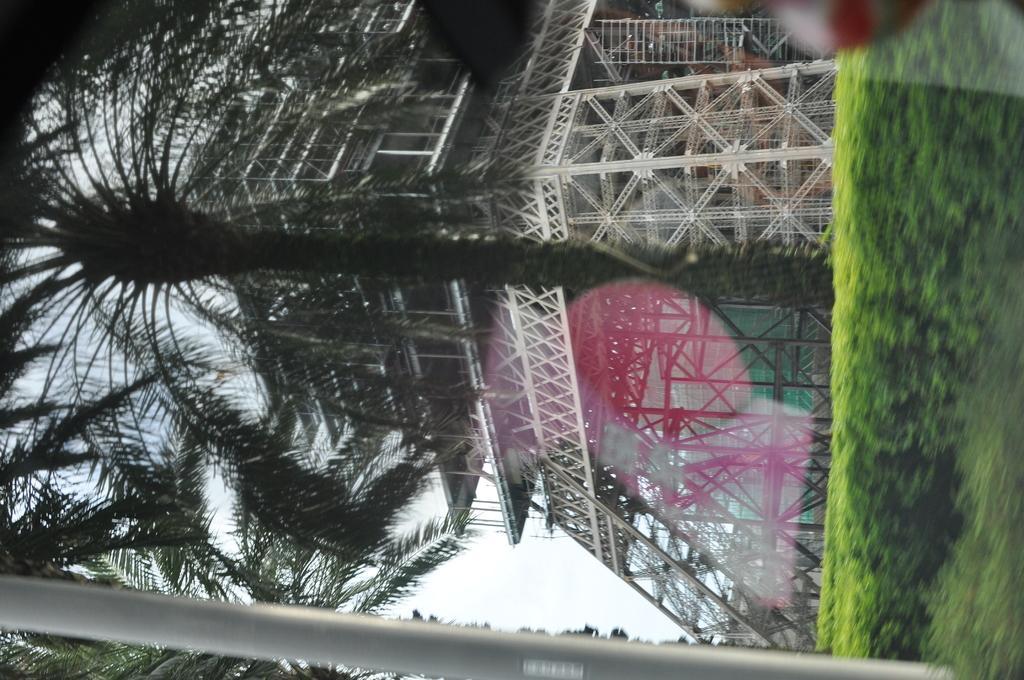Can you describe this image briefly? In this picture I can see constructing building, some trees and plants. 